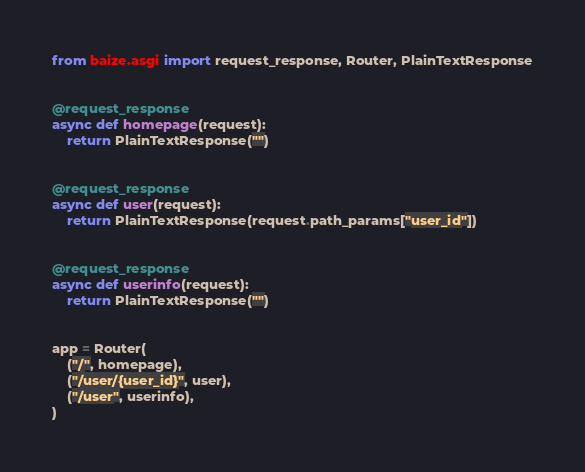<code> <loc_0><loc_0><loc_500><loc_500><_Python_>from baize.asgi import request_response, Router, PlainTextResponse


@request_response
async def homepage(request):
    return PlainTextResponse("")


@request_response
async def user(request):
    return PlainTextResponse(request.path_params["user_id"])


@request_response
async def userinfo(request):
    return PlainTextResponse("")


app = Router(
    ("/", homepage),
    ("/user/{user_id}", user),
    ("/user", userinfo),
)
</code> 